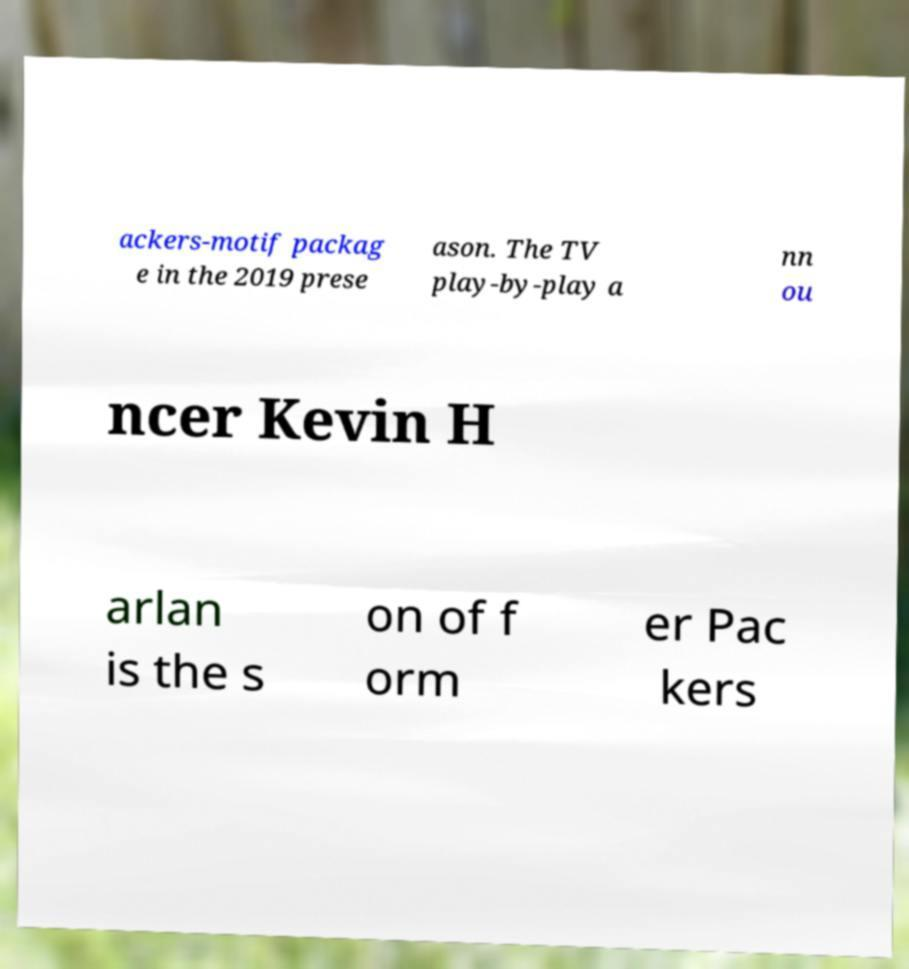Could you assist in decoding the text presented in this image and type it out clearly? ackers-motif packag e in the 2019 prese ason. The TV play-by-play a nn ou ncer Kevin H arlan is the s on of f orm er Pac kers 